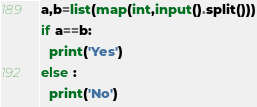Convert code to text. <code><loc_0><loc_0><loc_500><loc_500><_Python_>a,b=list(map(int,input().split()))
if a==b:
  print('Yes')
else :
  print('No')
</code> 